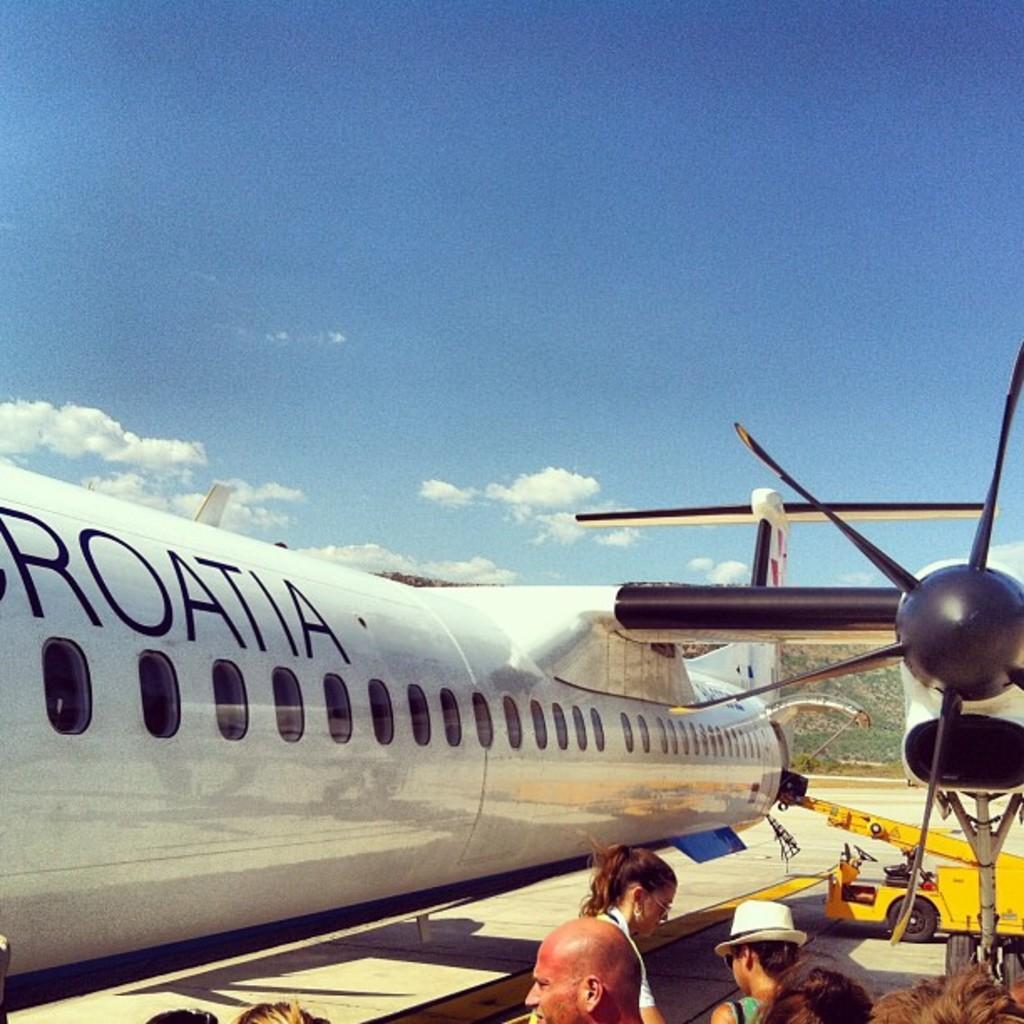Describe this image in one or two sentences. Here people are standing, this is airplane and a sky, this is vehicle. 